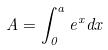<formula> <loc_0><loc_0><loc_500><loc_500>A = \int _ { 0 } ^ { a } e ^ { x } d x</formula> 